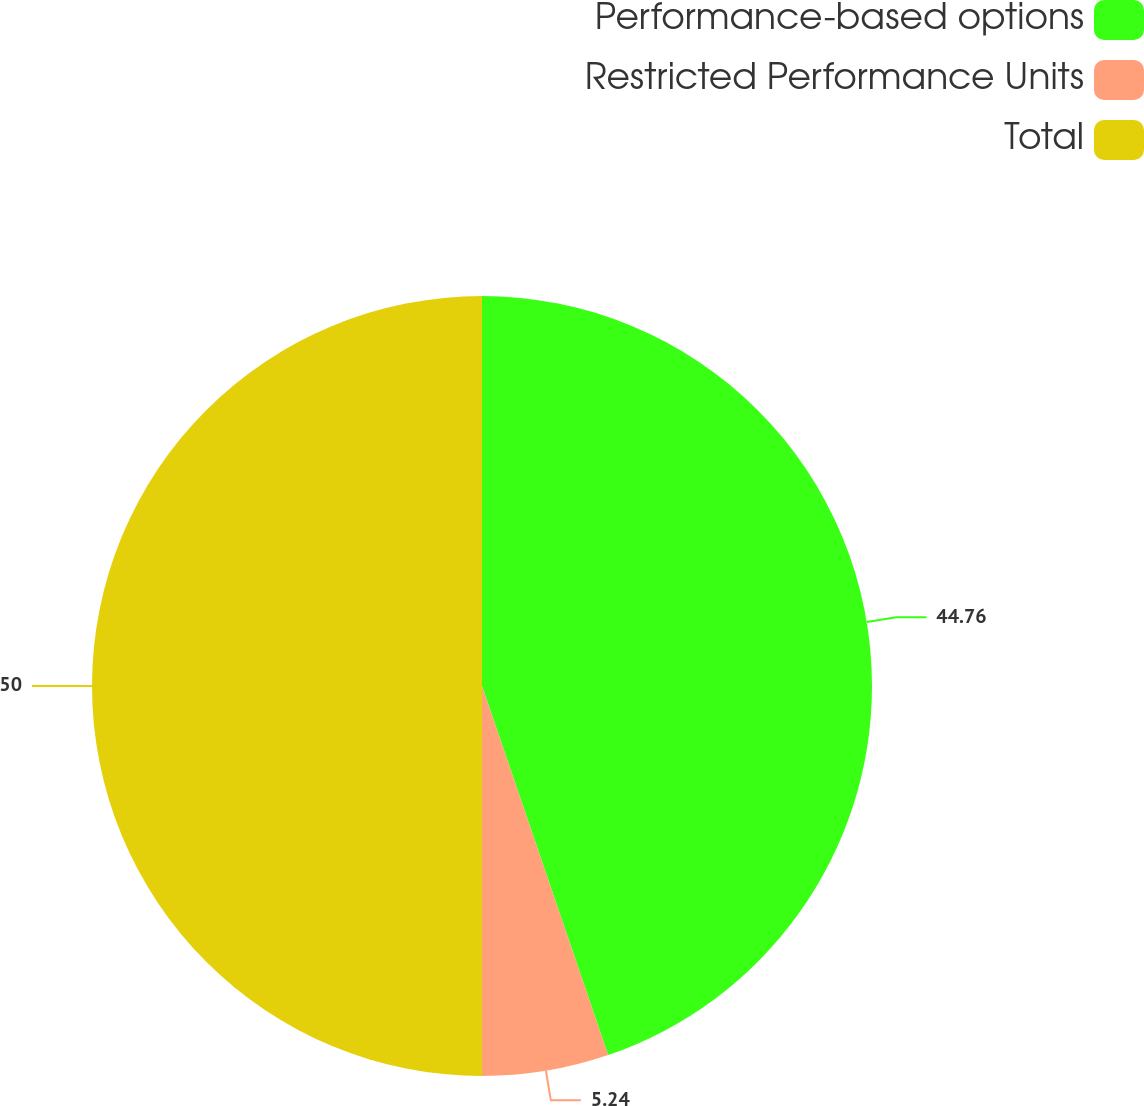Convert chart. <chart><loc_0><loc_0><loc_500><loc_500><pie_chart><fcel>Performance-based options<fcel>Restricted Performance Units<fcel>Total<nl><fcel>44.76%<fcel>5.24%<fcel>50.0%<nl></chart> 